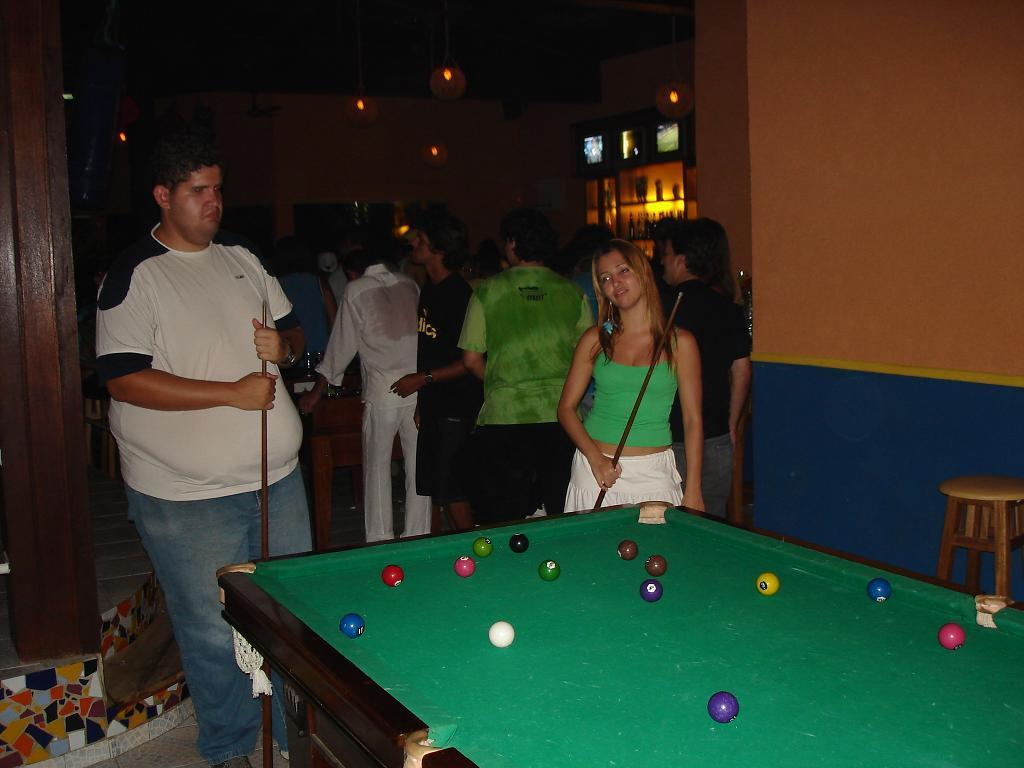What can be seen in the image involving people? There are people standing in the image. What is the main object in the image besides the people? There is a billiard board in the image. What is on top of the billiard board? There are balls on the billiard board. What type of nail is being used to hold the billiard board together in the image? There is no nail visible in the image, and the billiard board does not appear to be held together by nails. 